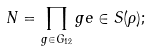<formula> <loc_0><loc_0><loc_500><loc_500>N = \prod _ { g \in G _ { 1 2 } } g e \in S ( \rho ) ;</formula> 